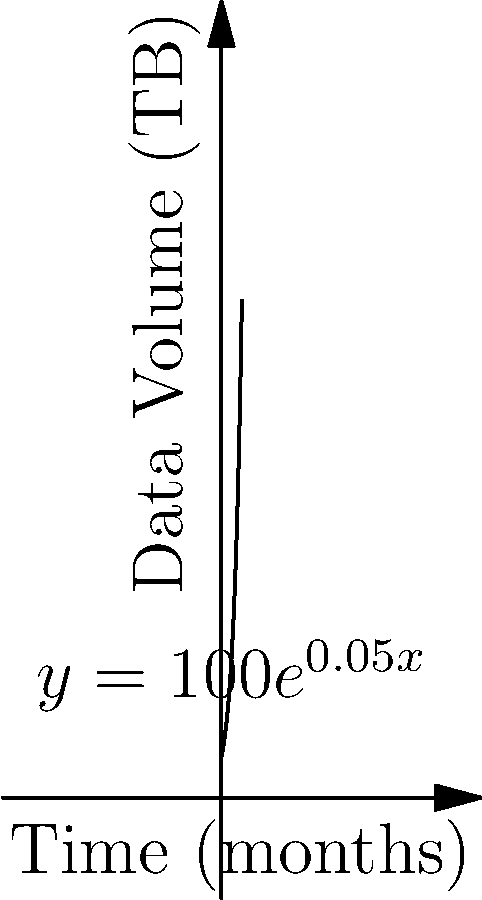A biotech company's data storage is growing exponentially. The current volume is 100 terabytes (TB), and it's increasing at a rate of 5% per month. Using the function $y = 100e^{0.05x}$, where $y$ is the data volume in TB and $x$ is the time in months, calculate the rate at which the data volume is changing after 24 months. To find the rate of change after 24 months, we need to calculate the derivative of the given function and evaluate it at x = 24.

1) The given function is $y = 100e^{0.05x}$

2) The derivative of $e^x$ is $e^x$, and using the chain rule, we get:
   $\frac{dy}{dx} = 100 \cdot 0.05 \cdot e^{0.05x} = 5e^{0.05x}$

3) This derivative represents the instantaneous rate of change of data volume with respect to time.

4) To find the rate of change at 24 months, substitute x = 24:
   $\frac{dy}{dx}|_{x=24} = 5e^{0.05(24)} = 5e^{1.2} \approx 16.58$

5) This means that after 24 months, the data volume is increasing at a rate of approximately 16.58 TB per month.
Answer: 16.58 TB per month 